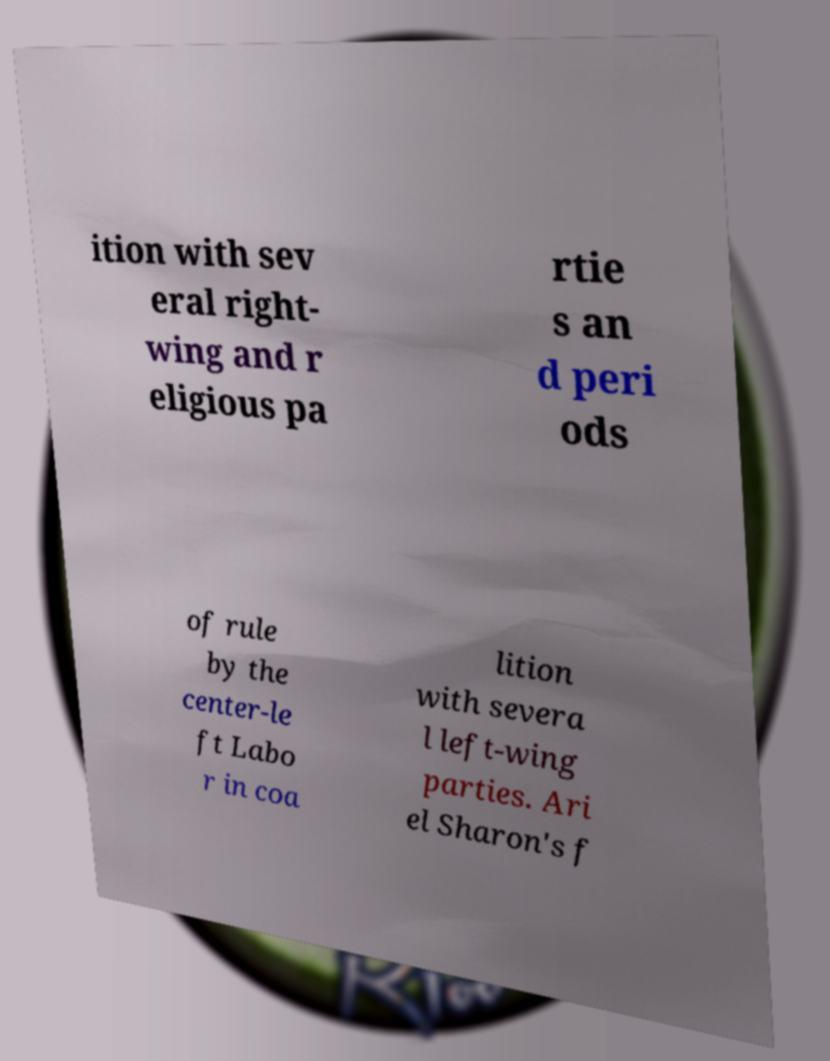Could you extract and type out the text from this image? ition with sev eral right- wing and r eligious pa rtie s an d peri ods of rule by the center-le ft Labo r in coa lition with severa l left-wing parties. Ari el Sharon's f 